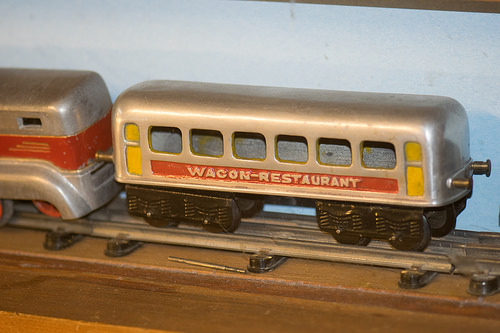<image>
Can you confirm if the train is on the wood? Yes. Looking at the image, I can see the train is positioned on top of the wood, with the wood providing support. 